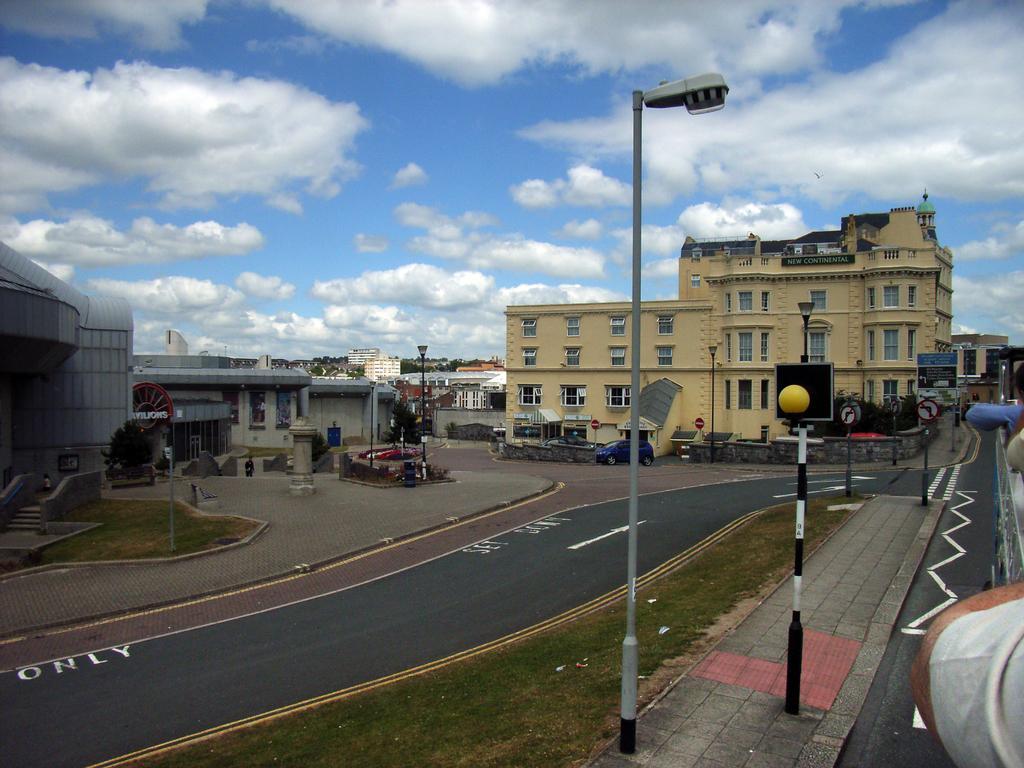How would you summarize this image in a sentence or two? This image is clicked on the roads. To the right, there is a bus on which there are many persons sitting. At the bottom, there is road. To the left, there is a building along with poles and plant. At the top, there are clouds in the sky. 